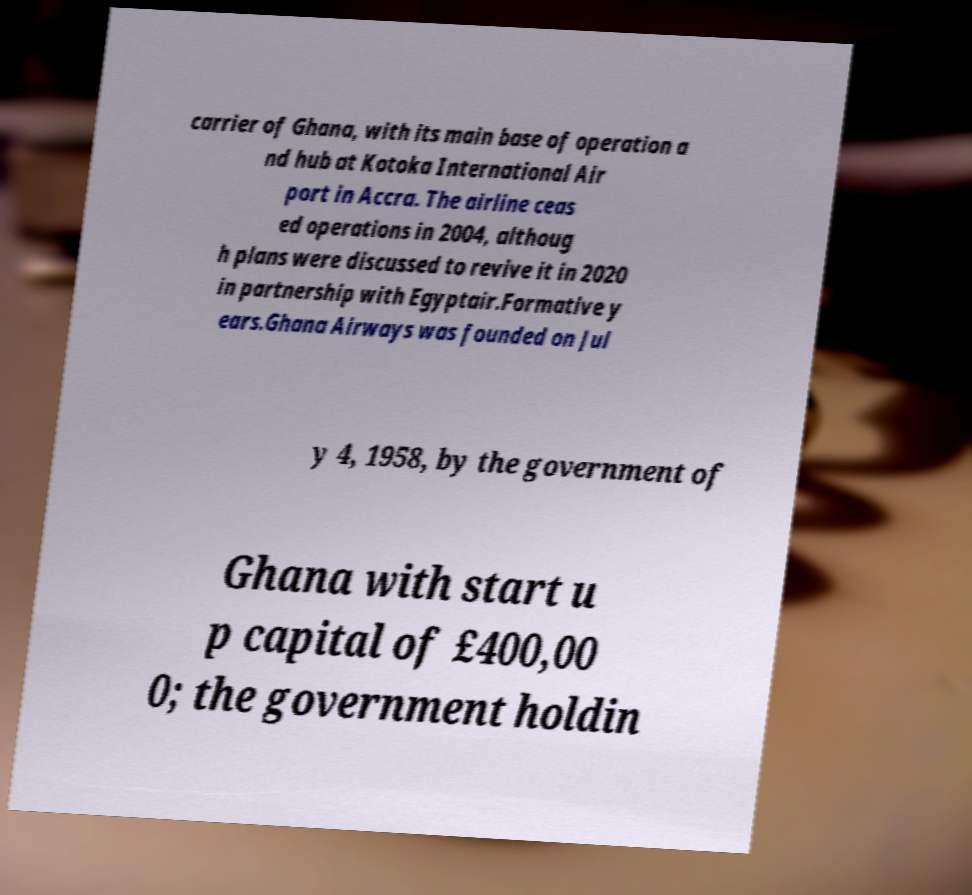Can you accurately transcribe the text from the provided image for me? carrier of Ghana, with its main base of operation a nd hub at Kotoka International Air port in Accra. The airline ceas ed operations in 2004, althoug h plans were discussed to revive it in 2020 in partnership with Egyptair.Formative y ears.Ghana Airways was founded on Jul y 4, 1958, by the government of Ghana with start u p capital of £400,00 0; the government holdin 